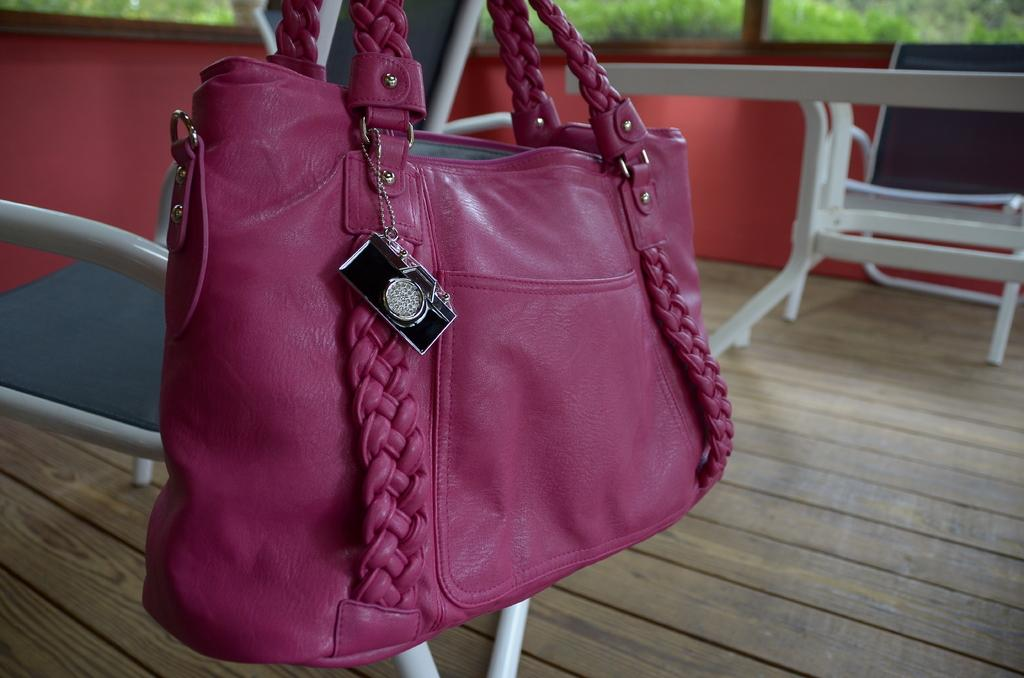What color is the bag that is visible in the image? The bag in the image is pink. Where is the pink bag located in the image? The pink bag is hanging on a chair. How many chairs are in the image? There are chairs in the image. What color is the wall in the background of the image? The wall in the background of the image is red. What type of flooring is present in the image? The chairs are on a wooden floor. Can you see any instruments being played on the wooden floor in the image? There are no instruments visible in the image; it only features a pink bag hanging on a chair, chairs, a red wall, and a wooden floor. 